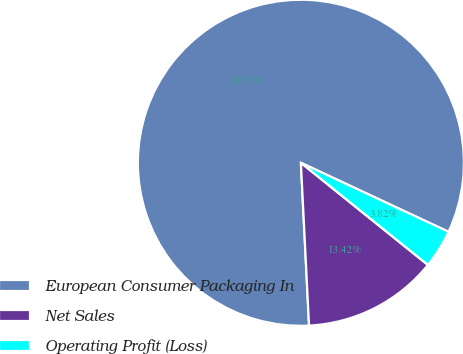Convert chart to OTSL. <chart><loc_0><loc_0><loc_500><loc_500><pie_chart><fcel>European Consumer Packaging In<fcel>Net Sales<fcel>Operating Profit (Loss)<nl><fcel>82.76%<fcel>13.42%<fcel>3.82%<nl></chart> 